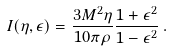<formula> <loc_0><loc_0><loc_500><loc_500>I ( \eta , \epsilon ) = \frac { 3 M ^ { 2 } \eta } { 1 0 \pi \rho } \frac { 1 + \epsilon ^ { 2 } } { 1 - \epsilon ^ { 2 } } \, .</formula> 